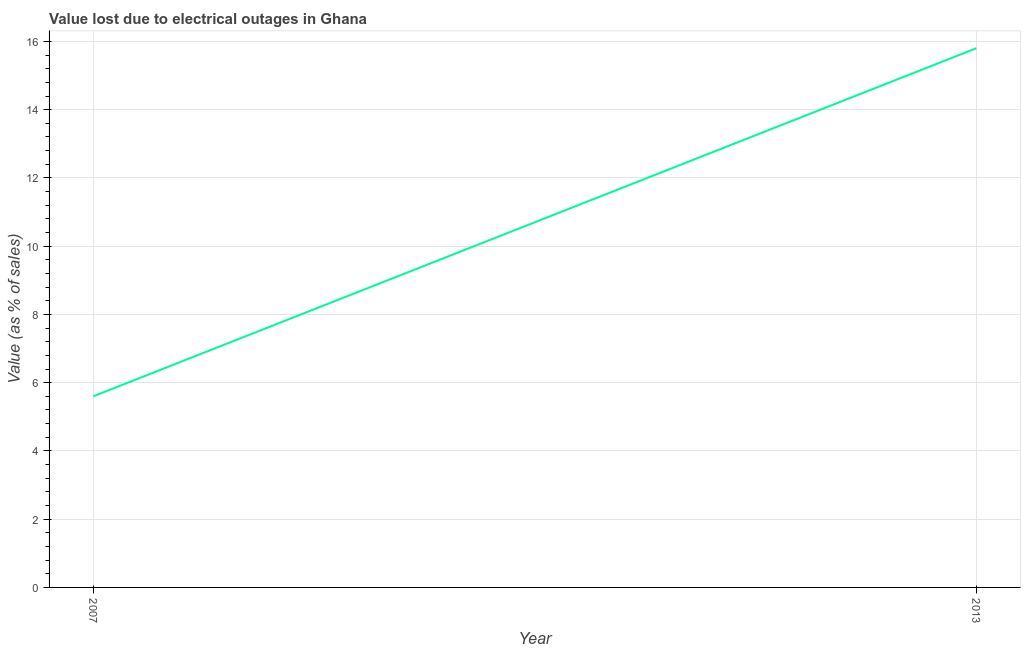What is the value lost due to electrical outages in 2007?
Make the answer very short. 5.6. Across all years, what is the maximum value lost due to electrical outages?
Give a very brief answer. 15.8. Across all years, what is the minimum value lost due to electrical outages?
Offer a very short reply. 5.6. What is the sum of the value lost due to electrical outages?
Offer a very short reply. 21.4. What is the difference between the value lost due to electrical outages in 2007 and 2013?
Provide a succinct answer. -10.2. What is the average value lost due to electrical outages per year?
Keep it short and to the point. 10.7. What is the median value lost due to electrical outages?
Your answer should be compact. 10.7. In how many years, is the value lost due to electrical outages greater than 8.4 %?
Provide a succinct answer. 1. What is the ratio of the value lost due to electrical outages in 2007 to that in 2013?
Your answer should be very brief. 0.35. In how many years, is the value lost due to electrical outages greater than the average value lost due to electrical outages taken over all years?
Provide a short and direct response. 1. How many lines are there?
Keep it short and to the point. 1. Are the values on the major ticks of Y-axis written in scientific E-notation?
Your response must be concise. No. Does the graph contain grids?
Your response must be concise. Yes. What is the title of the graph?
Provide a succinct answer. Value lost due to electrical outages in Ghana. What is the label or title of the X-axis?
Your answer should be very brief. Year. What is the label or title of the Y-axis?
Your answer should be compact. Value (as % of sales). What is the Value (as % of sales) of 2013?
Your answer should be very brief. 15.8. What is the ratio of the Value (as % of sales) in 2007 to that in 2013?
Make the answer very short. 0.35. 